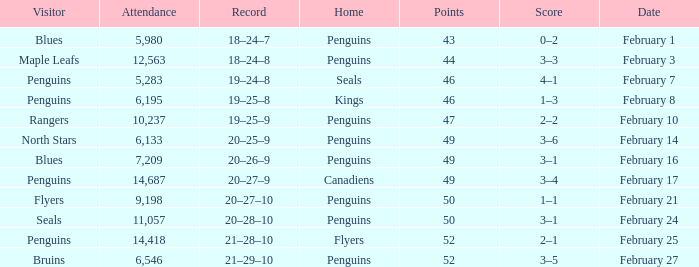Record of 21–29–10 had what total number of points? 1.0. 